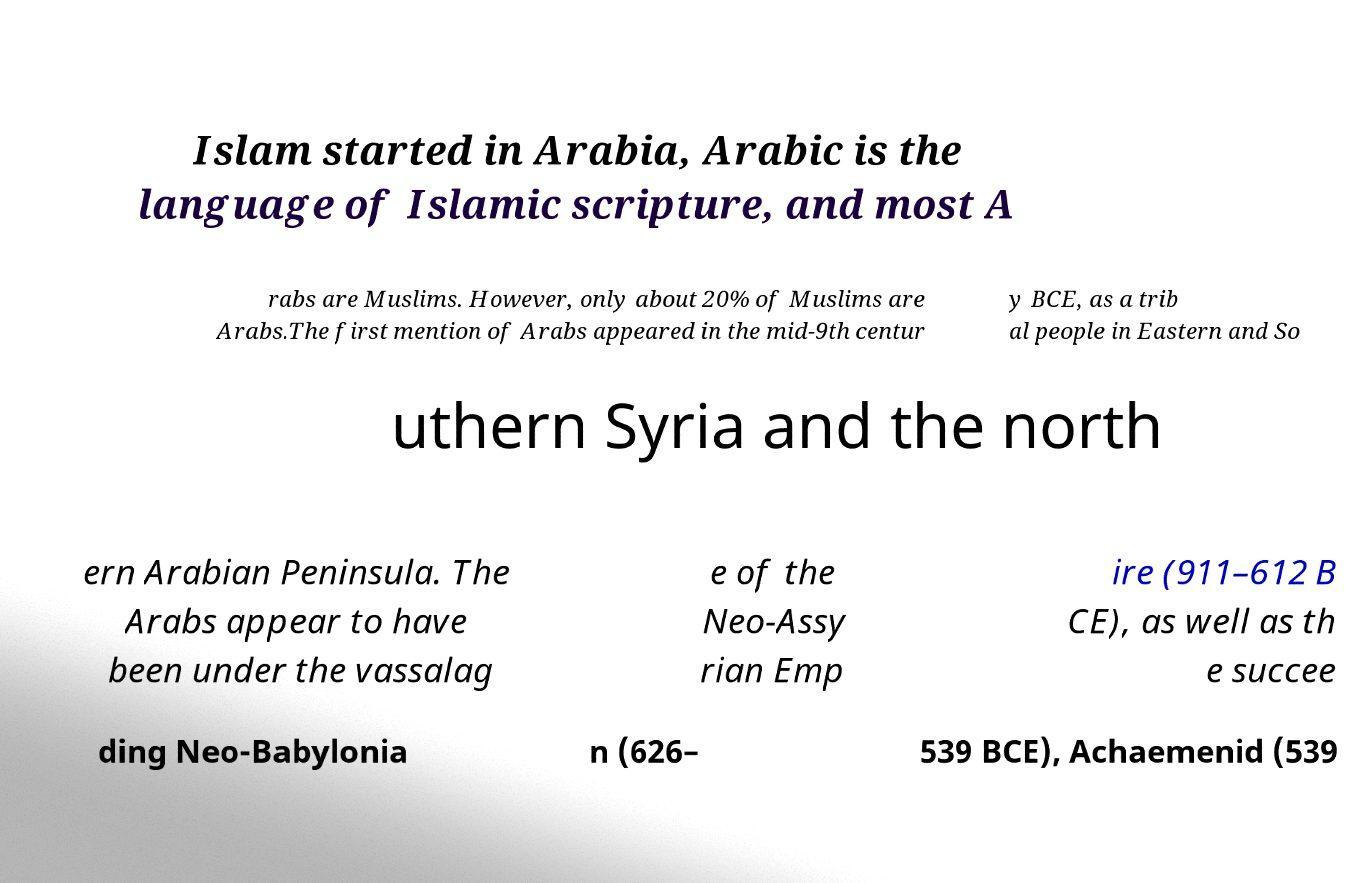Could you assist in decoding the text presented in this image and type it out clearly? Islam started in Arabia, Arabic is the language of Islamic scripture, and most A rabs are Muslims. However, only about 20% of Muslims are Arabs.The first mention of Arabs appeared in the mid-9th centur y BCE, as a trib al people in Eastern and So uthern Syria and the north ern Arabian Peninsula. The Arabs appear to have been under the vassalag e of the Neo-Assy rian Emp ire (911–612 B CE), as well as th e succee ding Neo-Babylonia n (626– 539 BCE), Achaemenid (539 